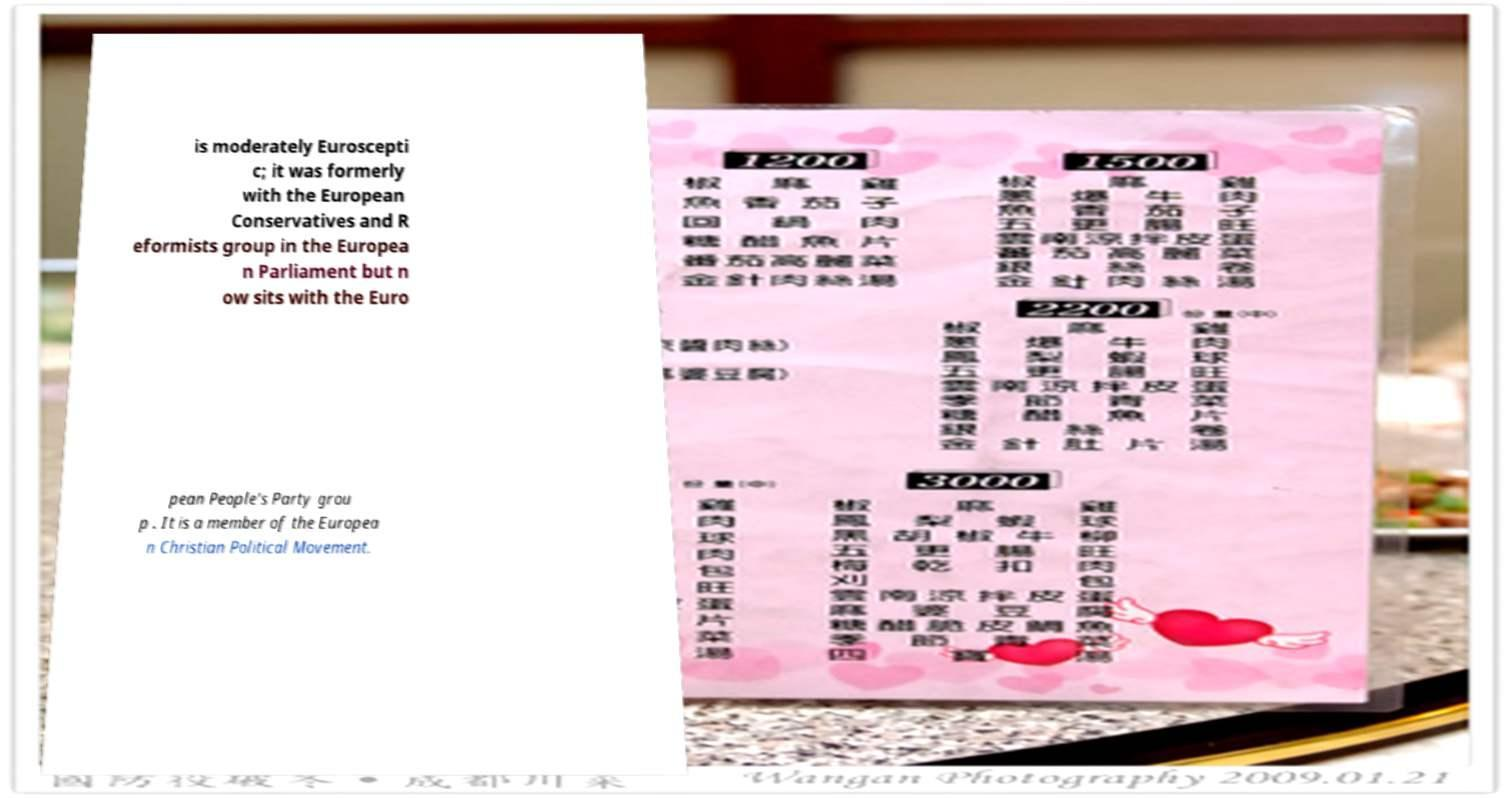Could you assist in decoding the text presented in this image and type it out clearly? is moderately Euroscepti c; it was formerly with the European Conservatives and R eformists group in the Europea n Parliament but n ow sits with the Euro pean People's Party grou p . It is a member of the Europea n Christian Political Movement. 